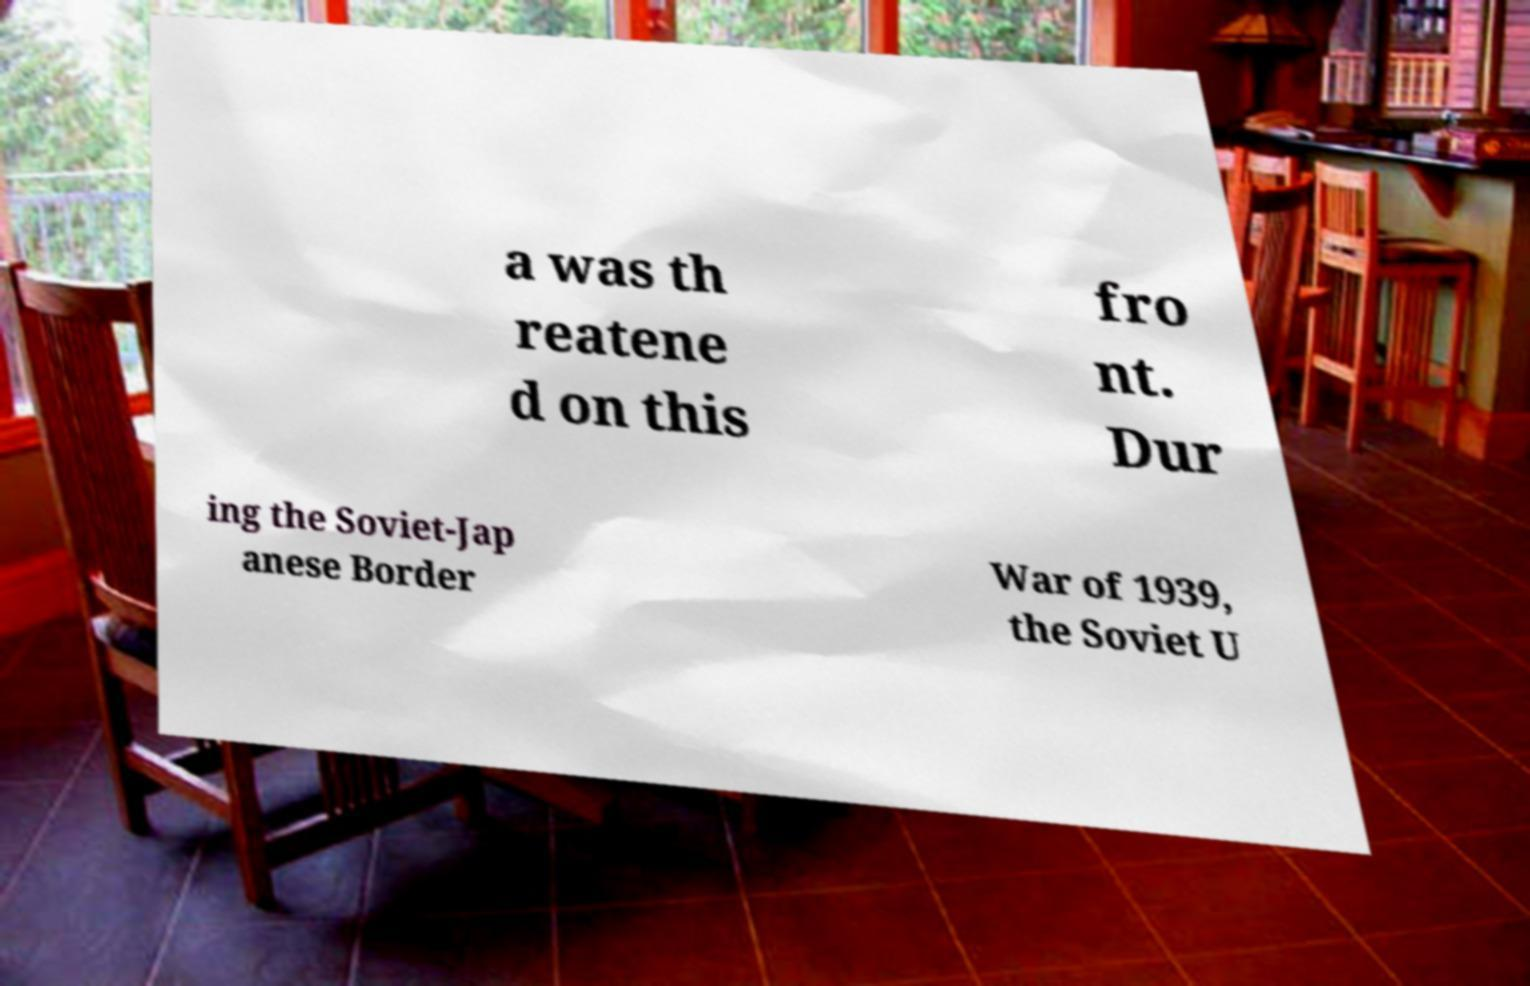For documentation purposes, I need the text within this image transcribed. Could you provide that? a was th reatene d on this fro nt. Dur ing the Soviet-Jap anese Border War of 1939, the Soviet U 